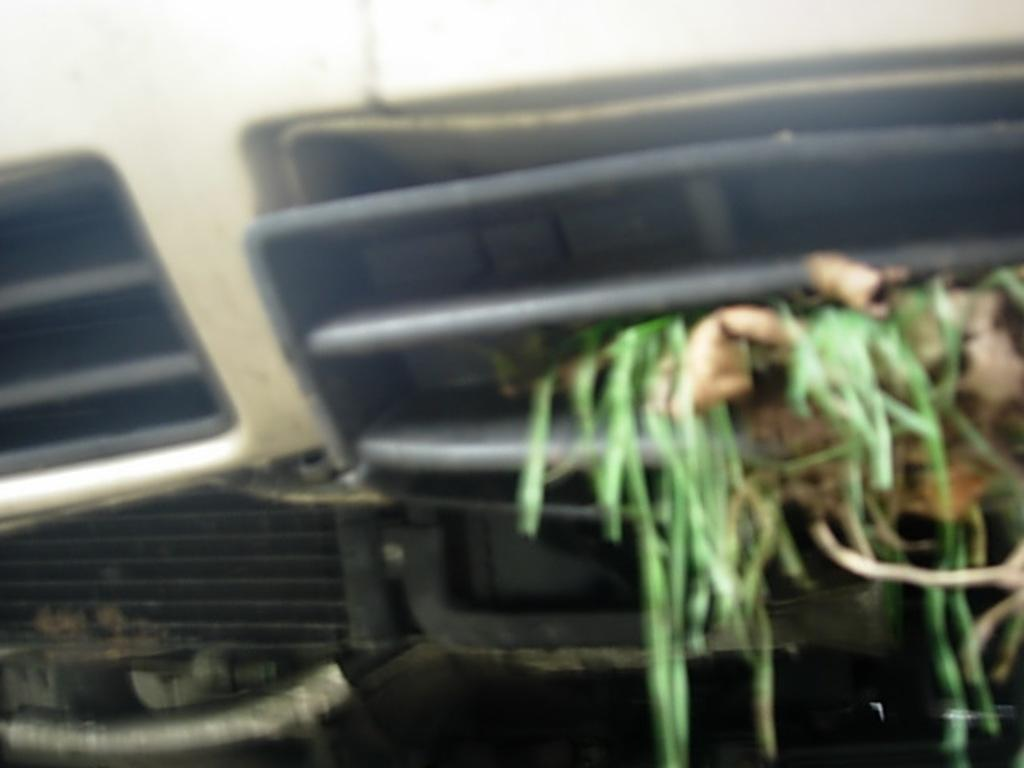What type of objects can be seen in the image? There are vehicle parts in the image. What type of natural environment is visible in the image? There is grass visible in the image. What type of motion can be observed in the vehicle parts in the image? There is no motion observed in the vehicle parts in the image; they are stationary. 